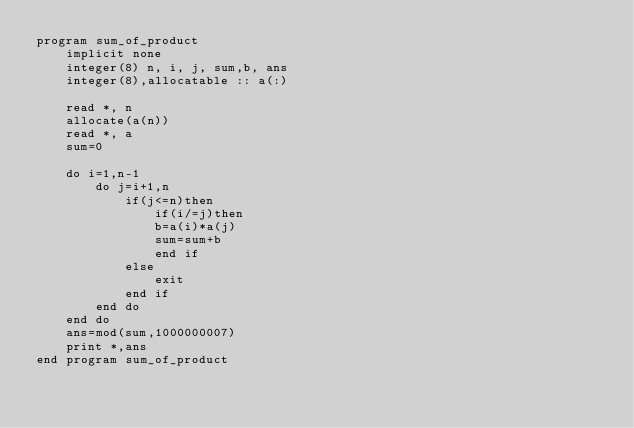<code> <loc_0><loc_0><loc_500><loc_500><_FORTRAN_>program sum_of_product
    implicit none
    integer(8) n, i, j, sum,b, ans
    integer(8),allocatable :: a(:)

    read *, n
    allocate(a(n))
    read *, a
    sum=0

    do i=1,n-1
        do j=i+1,n
            if(j<=n)then
                if(i/=j)then
                b=a(i)*a(j)
                sum=sum+b
                end if
            else
                exit
            end if
        end do
    end do
    ans=mod(sum,1000000007)
    print *,ans
end program sum_of_product</code> 